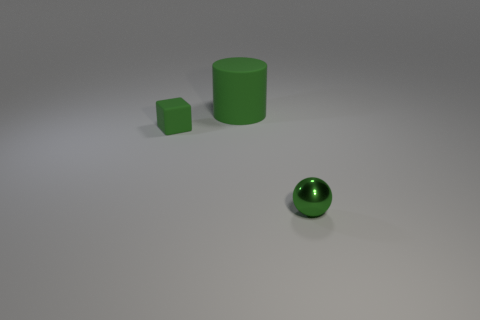There is a small object that is to the right of the small rubber block; how many matte objects are behind it?
Provide a short and direct response. 2. There is a thing that is in front of the tiny green block; is it the same shape as the small green object that is on the left side of the small metal sphere?
Provide a short and direct response. No. What size is the thing that is both behind the green sphere and in front of the big green rubber cylinder?
Provide a short and direct response. Small. What color is the small thing that is to the right of the green rubber thing that is behind the tiny green matte cube?
Offer a very short reply. Green. What shape is the big thing?
Your answer should be compact. Cylinder. There is a green thing that is right of the small cube and left of the tiny green sphere; what is its shape?
Provide a succinct answer. Cylinder. The thing that is made of the same material as the big green cylinder is what color?
Give a very brief answer. Green. There is a thing that is to the left of the green object that is behind the tiny object left of the sphere; what shape is it?
Make the answer very short. Cube. The green block is what size?
Your response must be concise. Small. What shape is the green object that is made of the same material as the cylinder?
Offer a very short reply. Cube. 